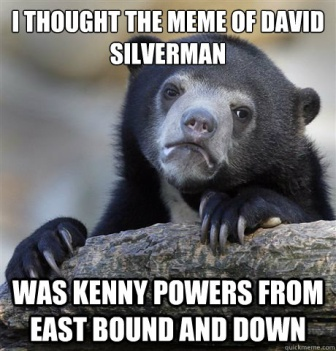Is there a deeper meaning to the bear’s expression and the text overlay? The bear’s expression, combined with the humorous text, might reflect the confusion and misunderstandings that often occur in everyday life. The meme portrays a relatable moment of realizing one’s mistake in a humorous way, emphasizing the importance of laughter and lightheartedness in dealing with such mix-ups.  If the bear could talk, what do you think it would say in this scenario? If the bear could talk, it might say something like, "Wait a minute, you're telling me David Silverman isn't Kenny Powers? Who knew?" This would match its puzzled look and add another layer of humor to the already funny meme.  Write a short dialogue between two other animals reacting to the bear’s confusion. Squirrel: "Hey, do you see that bear? What's got him looking so puzzled?"
Raccoon: "Oh, it’s just Barry again. He’s probably just figured out that David Silverman isn’t Kenny Powers."
Squirrel: "Seriously? You’d think he’d have better things to ponder in the forest."
Raccoon: "Well, better this than wondering where his next meal is coming from, right?"
Squirrel: "True, but it’s still funny to see him like that!" 